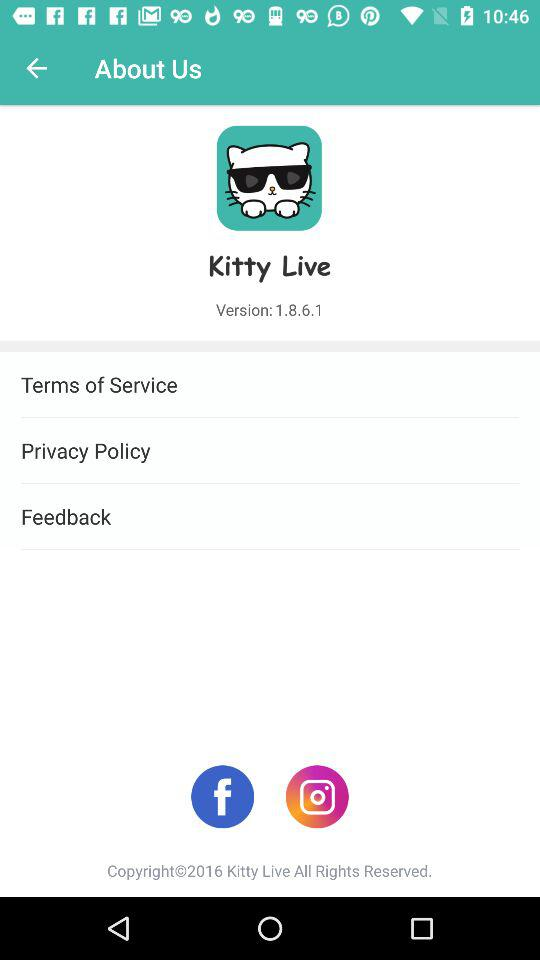What is the version? The version is 1.8.6.1. 